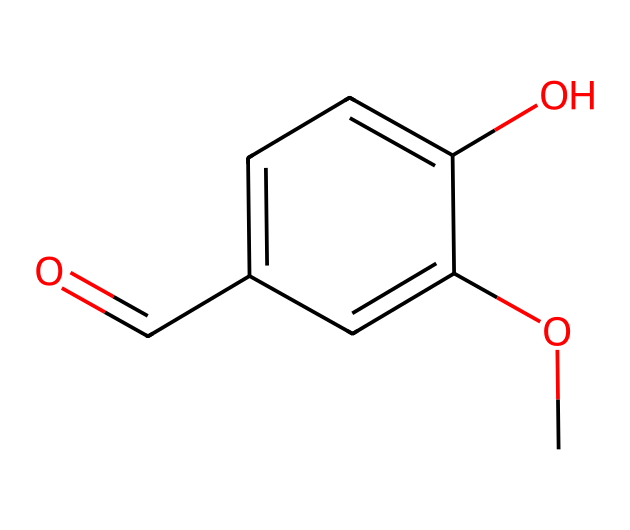What is the name of this chemical? The SMILES structure corresponds to vanillin, which is known for its characteristic vanilla flavor. This can be identified by recognizing the functional groups present, specifically the aldehyde and phenolic groups typical of vanillin.
Answer: vanillin How many carbon atoms are in vanillin? The SMILES representation shows the arrangement of the atoms, and by counting the 'c' (aromatic carbon) and 'C' (aliphatic carbon) symbols, there are 8 carbon atoms in total.
Answer: 8 Which functional group is responsible for vanillin's sweet aroma? The presence of the aldehyde functional group (-CHO) in the structure is what typically contributes to the sweet aroma of vanillin, identified by the 'O=' and direct bonding to a carbon atom in the structure.
Answer: aldehyde What is the total number of oxygen atoms in vanillin? By analyzing the SMILES, we can see there are two 'O' symbols—one in the aldehyde group and one in the methoxy group (–OCH3), so the total number is 2.
Answer: 2 Does vanillin contain any heteroatoms? The SMILES structure indicates the presence of oxygen atoms, which are heteroatoms as they are not carbon or hydrogen, confirming that vanillin does contain heteroatoms.
Answer: yes What type of chemical compound does vanillin belong to? Vanillin is categorized as an organosulfur compound due to the presence of organo-based functional groups, specifically characterized as a phenolic aldehyde in this context.
Answer: phenolic aldehyde How many hydrogen atoms are bonded to the structure of vanillin? Considering the saturation of the carbon atoms and the attached functional groups, there are a total of 8 hydrogen atoms bonded in the vanillin structure, ensuring each carbon achieves tetravalency.
Answer: 8 